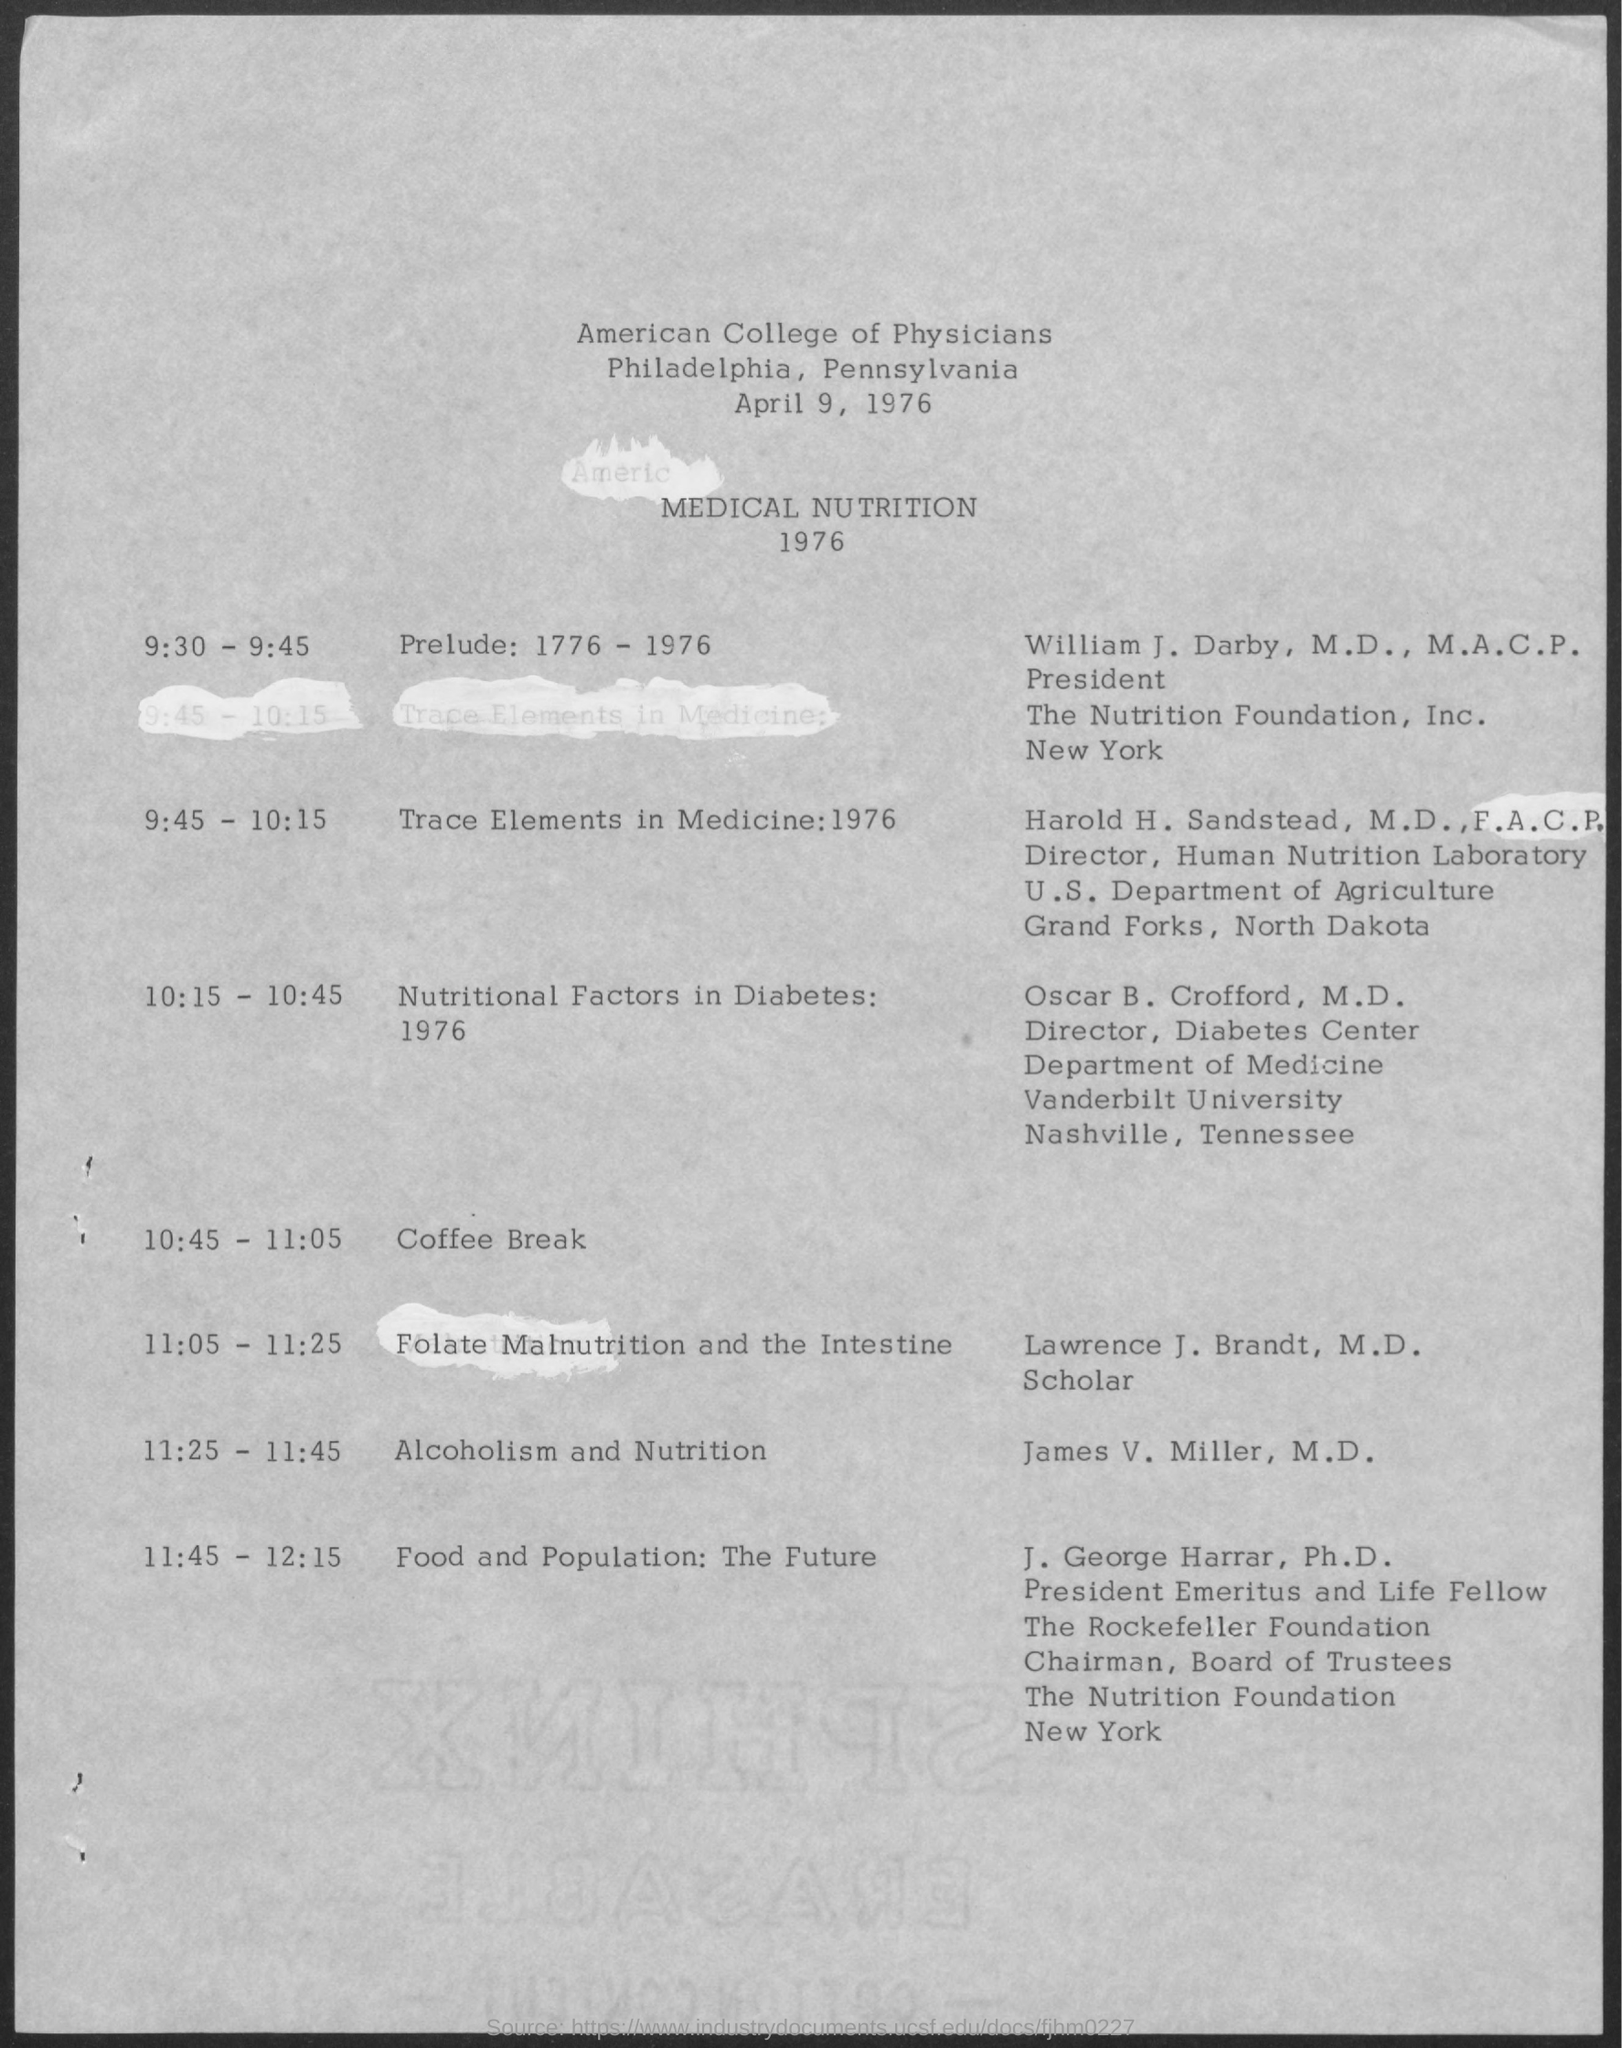What is the date mentioned ?
Ensure brevity in your answer.  APRIL 9, 1976. What is the schedule at the time of 10:45 - 11:05 ?
Keep it short and to the point. COFFEE BREAK. 